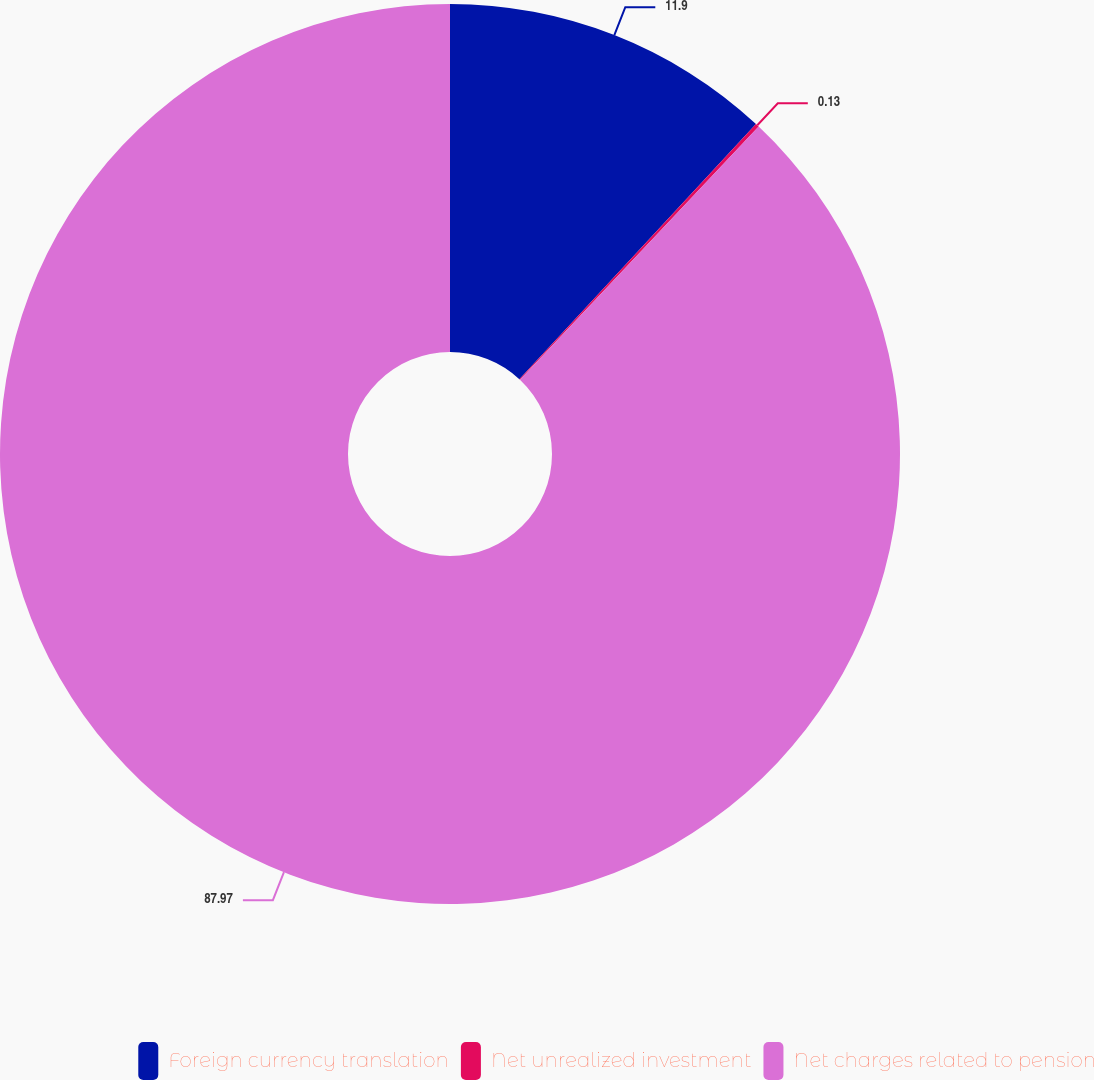Convert chart to OTSL. <chart><loc_0><loc_0><loc_500><loc_500><pie_chart><fcel>Foreign currency translation<fcel>Net unrealized investment<fcel>Net charges related to pension<nl><fcel>11.9%<fcel>0.13%<fcel>87.97%<nl></chart> 